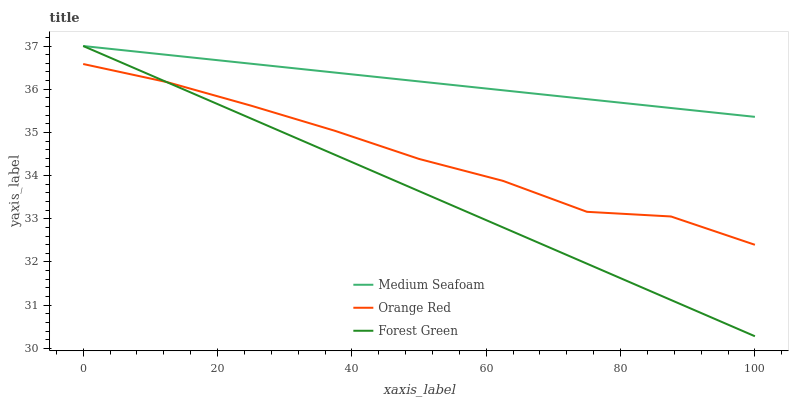Does Orange Red have the minimum area under the curve?
Answer yes or no. No. Does Orange Red have the maximum area under the curve?
Answer yes or no. No. Is Orange Red the smoothest?
Answer yes or no. No. Is Medium Seafoam the roughest?
Answer yes or no. No. Does Orange Red have the lowest value?
Answer yes or no. No. Does Orange Red have the highest value?
Answer yes or no. No. Is Orange Red less than Medium Seafoam?
Answer yes or no. Yes. Is Medium Seafoam greater than Orange Red?
Answer yes or no. Yes. Does Orange Red intersect Medium Seafoam?
Answer yes or no. No. 